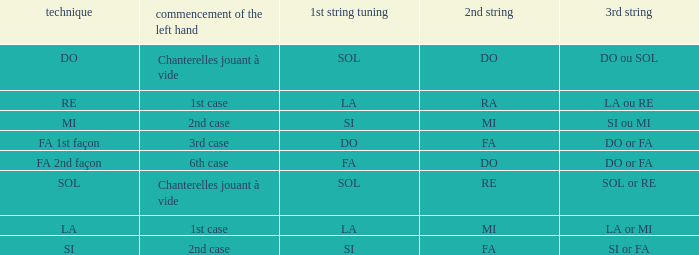What is the technique of the depart de la main gauche of 1st instance and a la or mi 3rd string? LA. 